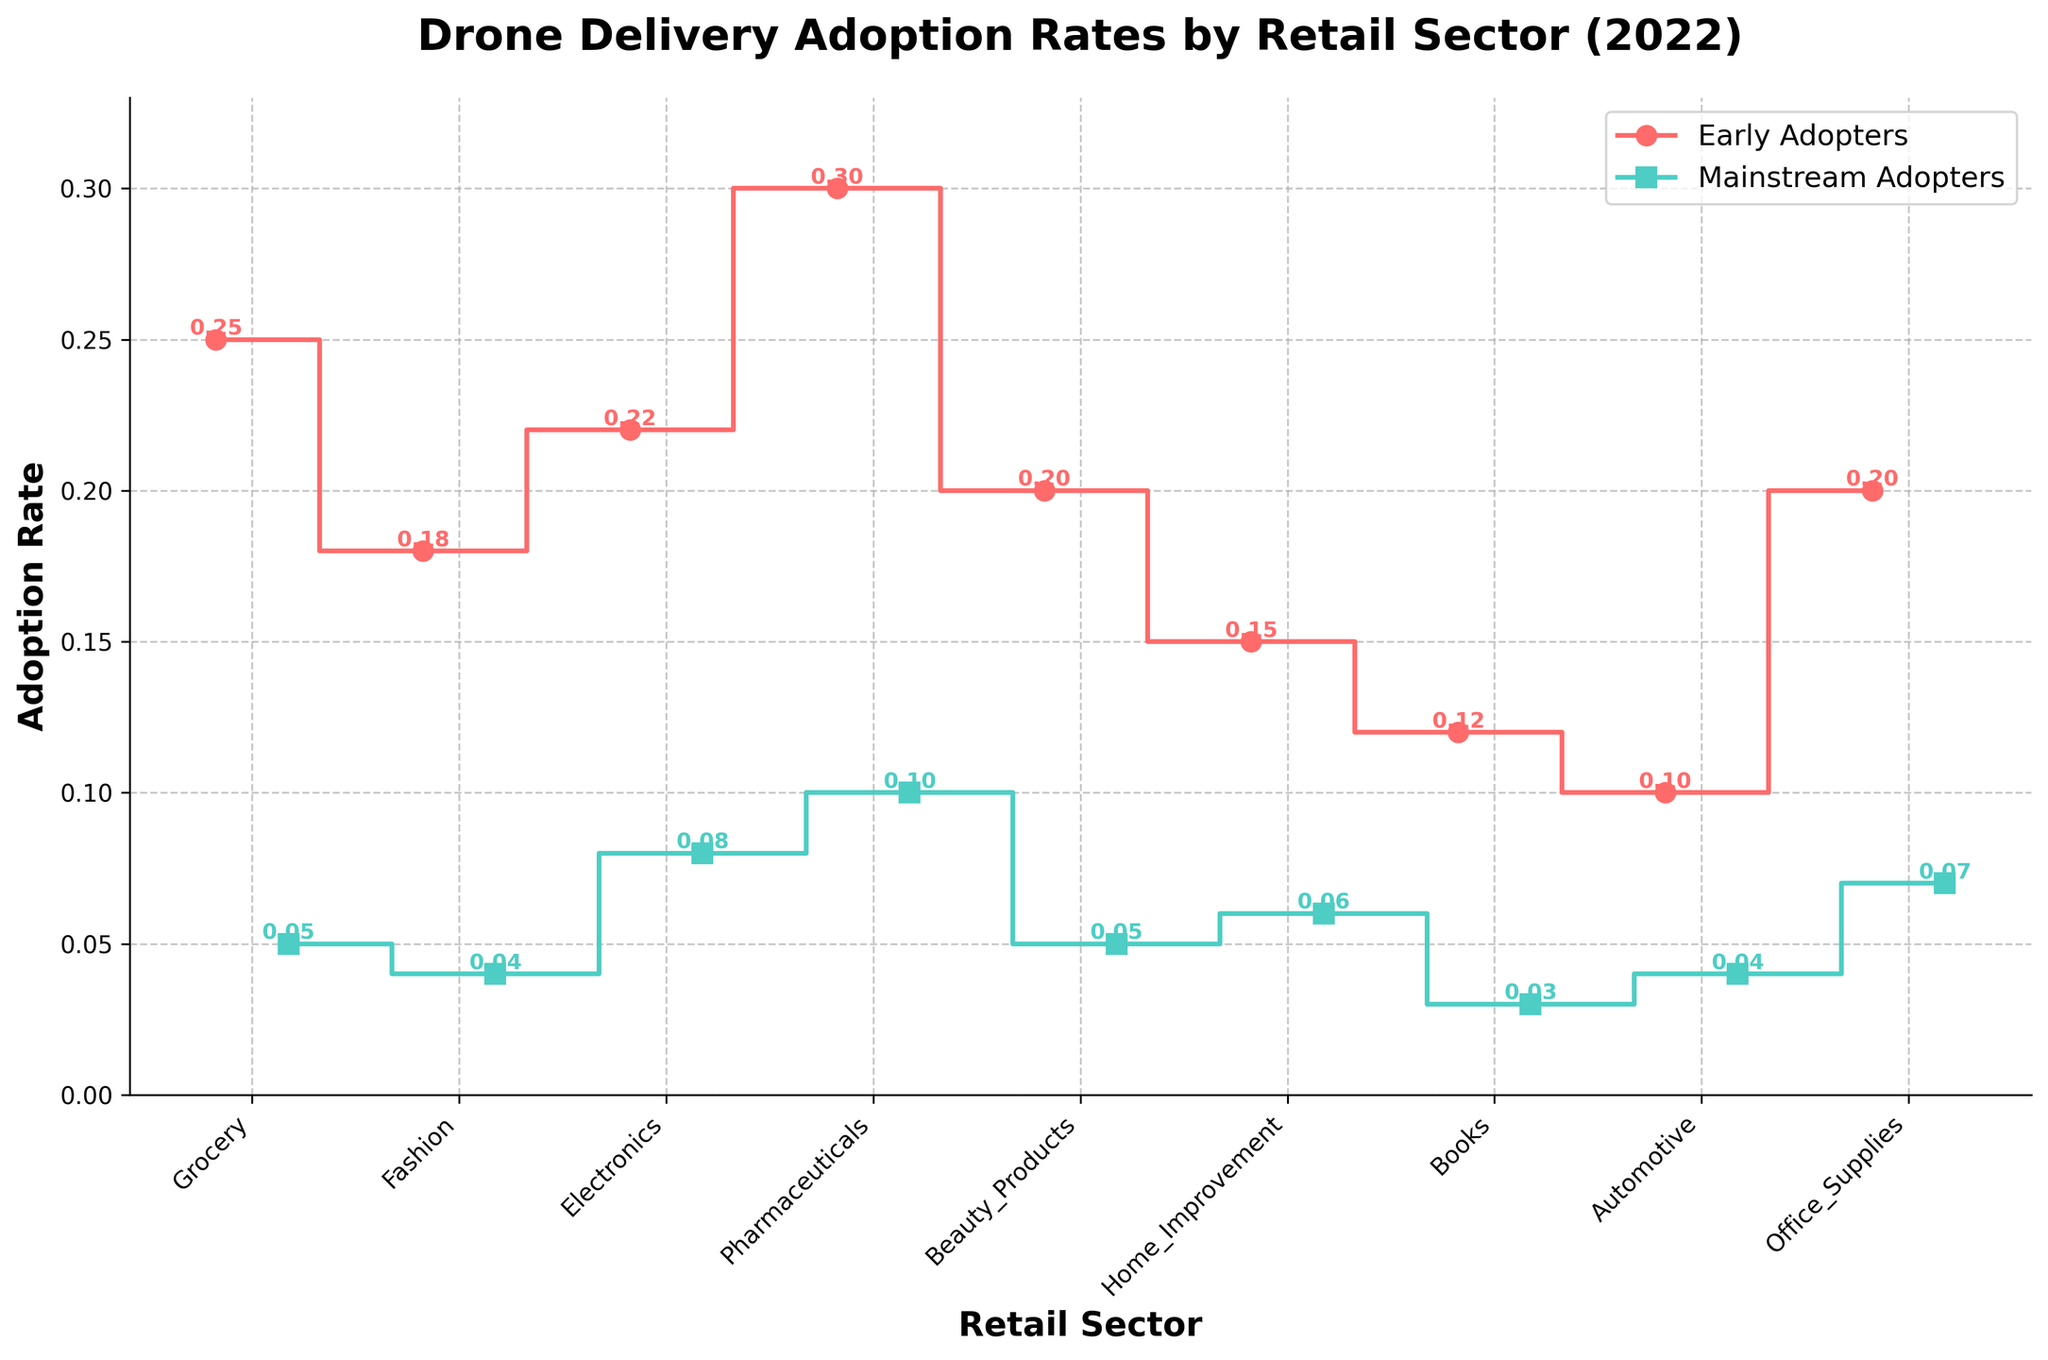What is the title of the figure? The title of the figure is prominently displayed at the top and gives an overview of what the figure represents, which is important for quickly understanding the purpose of the plot.
Answer: Drone Delivery Adoption Rates by Retail Sector (2022) Which retail sector has the highest rate of early adoption? By looking at the highest point of the 'Early Adopters' data series on the y-axis and noting the corresponding retail sector on the x-axis, we can find the sector with the highest early adoption rate.
Answer: Pharmaceuticals What's the difference in adoption rates between early adopters and mainstream adopters for the Electronics sector? Identify the y-values for both early adopters and mainstream adopters for the Electronics sector, and subtract the mainstream rate from the early adopter rate.
Answer: 0.14 Which retail sector has the lowest rate of mainstream adoption? By looking at the lowest point of the 'Mainstream Adopters' data series on the y-axis and noting the corresponding retail sector on the x-axis, we can find the sector with the lowest mainstream adoption rate.
Answer: Books What is the average adoption rate for early adopters across all sectors? Sum all the early adoption rates given on the plot and divide by the number of sectors to find the average.
Answer: 0.20 Which sector shows the smallest gap between early adopters and mainstream adopters? Calculate the difference between early adopter and mainstream adopter rates for each sector and find the sector with the smallest difference.
Answer: Automotive Between which two sectors does the mainstream adoption rate change the most? Look at the step changes in the 'Mainstream Adopters' data series and find the two adjacent sectors with the largest difference in their adoption rates.
Answer: Pharmaceuticals and Electronics What is the total adoption rate for both early adopters and mainstream adopters in the Grocery sector? Add the early adopter rate and the mainstream adopter rate for the Grocery sector to get the total adoption rate for that sector.
Answer: 0.30 Are there any retail sectors where the adoption rate for early adopters is less than or equal to the mainstream adopters? Check if any of the ‘Early Adopters’ data points are less than or equal to their corresponding 'Mainstream Adopters' data points.
Answer: No Which retail sector experienced the sharpest decline in adoption rates from early adopters to mainstream adopters? Calculate the absolute difference between early and mainstream adoption rates for each sector, then identify the sector with the highest value.
Answer: Grocery 